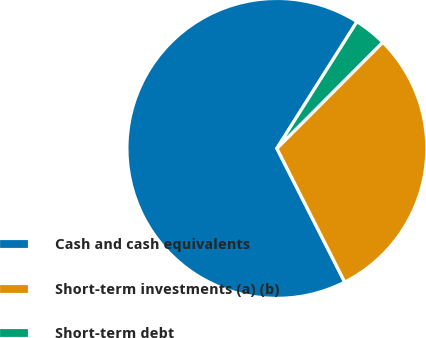Convert chart. <chart><loc_0><loc_0><loc_500><loc_500><pie_chart><fcel>Cash and cash equivalents<fcel>Short-term investments (a) (b)<fcel>Short-term debt<nl><fcel>66.44%<fcel>30.04%<fcel>3.51%<nl></chart> 